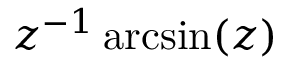Convert formula to latex. <formula><loc_0><loc_0><loc_500><loc_500>z ^ { - 1 } \arcsin ( z )</formula> 